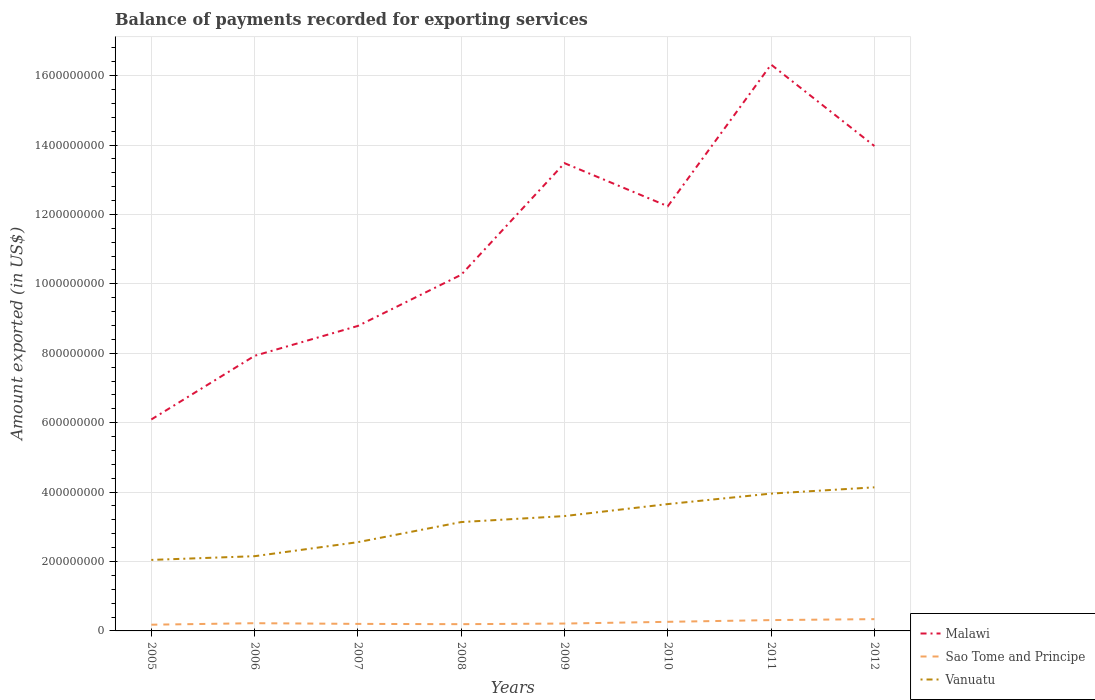How many different coloured lines are there?
Provide a short and direct response. 3. Does the line corresponding to Sao Tome and Principe intersect with the line corresponding to Malawi?
Your response must be concise. No. Is the number of lines equal to the number of legend labels?
Offer a very short reply. Yes. Across all years, what is the maximum amount exported in Sao Tome and Principe?
Your answer should be very brief. 1.79e+07. In which year was the amount exported in Vanuatu maximum?
Make the answer very short. 2005. What is the total amount exported in Sao Tome and Principe in the graph?
Your answer should be compact. 1.01e+06. What is the difference between the highest and the second highest amount exported in Sao Tome and Principe?
Ensure brevity in your answer.  1.60e+07. Is the amount exported in Vanuatu strictly greater than the amount exported in Malawi over the years?
Offer a terse response. Yes. How many lines are there?
Keep it short and to the point. 3. What is the difference between two consecutive major ticks on the Y-axis?
Your response must be concise. 2.00e+08. Are the values on the major ticks of Y-axis written in scientific E-notation?
Your answer should be compact. No. Does the graph contain any zero values?
Your response must be concise. No. Where does the legend appear in the graph?
Your response must be concise. Bottom right. What is the title of the graph?
Your answer should be compact. Balance of payments recorded for exporting services. What is the label or title of the X-axis?
Give a very brief answer. Years. What is the label or title of the Y-axis?
Your response must be concise. Amount exported (in US$). What is the Amount exported (in US$) of Malawi in 2005?
Your answer should be compact. 6.09e+08. What is the Amount exported (in US$) in Sao Tome and Principe in 2005?
Your response must be concise. 1.79e+07. What is the Amount exported (in US$) of Vanuatu in 2005?
Your answer should be very brief. 2.05e+08. What is the Amount exported (in US$) of Malawi in 2006?
Your answer should be very brief. 7.93e+08. What is the Amount exported (in US$) in Sao Tome and Principe in 2006?
Provide a succinct answer. 2.23e+07. What is the Amount exported (in US$) of Vanuatu in 2006?
Provide a succinct answer. 2.15e+08. What is the Amount exported (in US$) of Malawi in 2007?
Your response must be concise. 8.79e+08. What is the Amount exported (in US$) of Sao Tome and Principe in 2007?
Offer a terse response. 2.03e+07. What is the Amount exported (in US$) of Vanuatu in 2007?
Provide a succinct answer. 2.56e+08. What is the Amount exported (in US$) in Malawi in 2008?
Your response must be concise. 1.03e+09. What is the Amount exported (in US$) in Sao Tome and Principe in 2008?
Provide a short and direct response. 1.94e+07. What is the Amount exported (in US$) of Vanuatu in 2008?
Offer a very short reply. 3.14e+08. What is the Amount exported (in US$) in Malawi in 2009?
Give a very brief answer. 1.35e+09. What is the Amount exported (in US$) in Sao Tome and Principe in 2009?
Provide a short and direct response. 2.13e+07. What is the Amount exported (in US$) in Vanuatu in 2009?
Offer a terse response. 3.31e+08. What is the Amount exported (in US$) in Malawi in 2010?
Your answer should be compact. 1.22e+09. What is the Amount exported (in US$) of Sao Tome and Principe in 2010?
Offer a terse response. 2.62e+07. What is the Amount exported (in US$) of Vanuatu in 2010?
Your response must be concise. 3.65e+08. What is the Amount exported (in US$) of Malawi in 2011?
Your answer should be very brief. 1.63e+09. What is the Amount exported (in US$) in Sao Tome and Principe in 2011?
Offer a very short reply. 3.12e+07. What is the Amount exported (in US$) of Vanuatu in 2011?
Offer a terse response. 3.96e+08. What is the Amount exported (in US$) of Malawi in 2012?
Give a very brief answer. 1.40e+09. What is the Amount exported (in US$) of Sao Tome and Principe in 2012?
Give a very brief answer. 3.40e+07. What is the Amount exported (in US$) in Vanuatu in 2012?
Make the answer very short. 4.14e+08. Across all years, what is the maximum Amount exported (in US$) in Malawi?
Ensure brevity in your answer.  1.63e+09. Across all years, what is the maximum Amount exported (in US$) in Sao Tome and Principe?
Make the answer very short. 3.40e+07. Across all years, what is the maximum Amount exported (in US$) of Vanuatu?
Give a very brief answer. 4.14e+08. Across all years, what is the minimum Amount exported (in US$) of Malawi?
Provide a succinct answer. 6.09e+08. Across all years, what is the minimum Amount exported (in US$) in Sao Tome and Principe?
Your response must be concise. 1.79e+07. Across all years, what is the minimum Amount exported (in US$) in Vanuatu?
Offer a very short reply. 2.05e+08. What is the total Amount exported (in US$) of Malawi in the graph?
Make the answer very short. 8.91e+09. What is the total Amount exported (in US$) of Sao Tome and Principe in the graph?
Your answer should be compact. 1.93e+08. What is the total Amount exported (in US$) in Vanuatu in the graph?
Your answer should be very brief. 2.50e+09. What is the difference between the Amount exported (in US$) in Malawi in 2005 and that in 2006?
Keep it short and to the point. -1.83e+08. What is the difference between the Amount exported (in US$) of Sao Tome and Principe in 2005 and that in 2006?
Your response must be concise. -4.35e+06. What is the difference between the Amount exported (in US$) of Vanuatu in 2005 and that in 2006?
Provide a succinct answer. -1.07e+07. What is the difference between the Amount exported (in US$) of Malawi in 2005 and that in 2007?
Make the answer very short. -2.70e+08. What is the difference between the Amount exported (in US$) of Sao Tome and Principe in 2005 and that in 2007?
Offer a terse response. -2.36e+06. What is the difference between the Amount exported (in US$) in Vanuatu in 2005 and that in 2007?
Give a very brief answer. -5.11e+07. What is the difference between the Amount exported (in US$) in Malawi in 2005 and that in 2008?
Keep it short and to the point. -4.17e+08. What is the difference between the Amount exported (in US$) of Sao Tome and Principe in 2005 and that in 2008?
Your answer should be very brief. -1.53e+06. What is the difference between the Amount exported (in US$) of Vanuatu in 2005 and that in 2008?
Your answer should be compact. -1.09e+08. What is the difference between the Amount exported (in US$) of Malawi in 2005 and that in 2009?
Your answer should be compact. -7.39e+08. What is the difference between the Amount exported (in US$) in Sao Tome and Principe in 2005 and that in 2009?
Make the answer very short. -3.34e+06. What is the difference between the Amount exported (in US$) in Vanuatu in 2005 and that in 2009?
Provide a succinct answer. -1.26e+08. What is the difference between the Amount exported (in US$) of Malawi in 2005 and that in 2010?
Make the answer very short. -6.14e+08. What is the difference between the Amount exported (in US$) of Sao Tome and Principe in 2005 and that in 2010?
Provide a succinct answer. -8.30e+06. What is the difference between the Amount exported (in US$) of Vanuatu in 2005 and that in 2010?
Your answer should be very brief. -1.61e+08. What is the difference between the Amount exported (in US$) of Malawi in 2005 and that in 2011?
Your response must be concise. -1.02e+09. What is the difference between the Amount exported (in US$) in Sao Tome and Principe in 2005 and that in 2011?
Provide a short and direct response. -1.33e+07. What is the difference between the Amount exported (in US$) of Vanuatu in 2005 and that in 2011?
Give a very brief answer. -1.91e+08. What is the difference between the Amount exported (in US$) of Malawi in 2005 and that in 2012?
Keep it short and to the point. -7.88e+08. What is the difference between the Amount exported (in US$) in Sao Tome and Principe in 2005 and that in 2012?
Provide a short and direct response. -1.60e+07. What is the difference between the Amount exported (in US$) in Vanuatu in 2005 and that in 2012?
Offer a very short reply. -2.09e+08. What is the difference between the Amount exported (in US$) in Malawi in 2006 and that in 2007?
Offer a very short reply. -8.61e+07. What is the difference between the Amount exported (in US$) of Sao Tome and Principe in 2006 and that in 2007?
Keep it short and to the point. 1.99e+06. What is the difference between the Amount exported (in US$) in Vanuatu in 2006 and that in 2007?
Give a very brief answer. -4.04e+07. What is the difference between the Amount exported (in US$) in Malawi in 2006 and that in 2008?
Your answer should be compact. -2.33e+08. What is the difference between the Amount exported (in US$) of Sao Tome and Principe in 2006 and that in 2008?
Give a very brief answer. 2.82e+06. What is the difference between the Amount exported (in US$) of Vanuatu in 2006 and that in 2008?
Offer a very short reply. -9.83e+07. What is the difference between the Amount exported (in US$) in Malawi in 2006 and that in 2009?
Your response must be concise. -5.55e+08. What is the difference between the Amount exported (in US$) of Sao Tome and Principe in 2006 and that in 2009?
Ensure brevity in your answer.  1.01e+06. What is the difference between the Amount exported (in US$) of Vanuatu in 2006 and that in 2009?
Give a very brief answer. -1.16e+08. What is the difference between the Amount exported (in US$) in Malawi in 2006 and that in 2010?
Ensure brevity in your answer.  -4.31e+08. What is the difference between the Amount exported (in US$) of Sao Tome and Principe in 2006 and that in 2010?
Offer a very short reply. -3.94e+06. What is the difference between the Amount exported (in US$) in Vanuatu in 2006 and that in 2010?
Give a very brief answer. -1.50e+08. What is the difference between the Amount exported (in US$) of Malawi in 2006 and that in 2011?
Keep it short and to the point. -8.39e+08. What is the difference between the Amount exported (in US$) in Sao Tome and Principe in 2006 and that in 2011?
Make the answer very short. -8.94e+06. What is the difference between the Amount exported (in US$) of Vanuatu in 2006 and that in 2011?
Ensure brevity in your answer.  -1.80e+08. What is the difference between the Amount exported (in US$) in Malawi in 2006 and that in 2012?
Ensure brevity in your answer.  -6.05e+08. What is the difference between the Amount exported (in US$) of Sao Tome and Principe in 2006 and that in 2012?
Your answer should be compact. -1.17e+07. What is the difference between the Amount exported (in US$) in Vanuatu in 2006 and that in 2012?
Your answer should be very brief. -1.98e+08. What is the difference between the Amount exported (in US$) in Malawi in 2007 and that in 2008?
Give a very brief answer. -1.47e+08. What is the difference between the Amount exported (in US$) of Sao Tome and Principe in 2007 and that in 2008?
Offer a very short reply. 8.26e+05. What is the difference between the Amount exported (in US$) in Vanuatu in 2007 and that in 2008?
Provide a succinct answer. -5.79e+07. What is the difference between the Amount exported (in US$) in Malawi in 2007 and that in 2009?
Provide a short and direct response. -4.69e+08. What is the difference between the Amount exported (in US$) in Sao Tome and Principe in 2007 and that in 2009?
Your answer should be compact. -9.81e+05. What is the difference between the Amount exported (in US$) of Vanuatu in 2007 and that in 2009?
Offer a very short reply. -7.52e+07. What is the difference between the Amount exported (in US$) of Malawi in 2007 and that in 2010?
Provide a succinct answer. -3.45e+08. What is the difference between the Amount exported (in US$) in Sao Tome and Principe in 2007 and that in 2010?
Provide a succinct answer. -5.93e+06. What is the difference between the Amount exported (in US$) in Vanuatu in 2007 and that in 2010?
Your response must be concise. -1.10e+08. What is the difference between the Amount exported (in US$) in Malawi in 2007 and that in 2011?
Offer a terse response. -7.53e+08. What is the difference between the Amount exported (in US$) in Sao Tome and Principe in 2007 and that in 2011?
Ensure brevity in your answer.  -1.09e+07. What is the difference between the Amount exported (in US$) of Vanuatu in 2007 and that in 2011?
Give a very brief answer. -1.40e+08. What is the difference between the Amount exported (in US$) in Malawi in 2007 and that in 2012?
Offer a very short reply. -5.18e+08. What is the difference between the Amount exported (in US$) in Sao Tome and Principe in 2007 and that in 2012?
Provide a short and direct response. -1.37e+07. What is the difference between the Amount exported (in US$) in Vanuatu in 2007 and that in 2012?
Keep it short and to the point. -1.58e+08. What is the difference between the Amount exported (in US$) of Malawi in 2008 and that in 2009?
Offer a very short reply. -3.22e+08. What is the difference between the Amount exported (in US$) in Sao Tome and Principe in 2008 and that in 2009?
Your response must be concise. -1.81e+06. What is the difference between the Amount exported (in US$) of Vanuatu in 2008 and that in 2009?
Offer a very short reply. -1.73e+07. What is the difference between the Amount exported (in US$) in Malawi in 2008 and that in 2010?
Make the answer very short. -1.97e+08. What is the difference between the Amount exported (in US$) of Sao Tome and Principe in 2008 and that in 2010?
Offer a very short reply. -6.76e+06. What is the difference between the Amount exported (in US$) of Vanuatu in 2008 and that in 2010?
Your answer should be compact. -5.18e+07. What is the difference between the Amount exported (in US$) in Malawi in 2008 and that in 2011?
Provide a short and direct response. -6.06e+08. What is the difference between the Amount exported (in US$) of Sao Tome and Principe in 2008 and that in 2011?
Keep it short and to the point. -1.18e+07. What is the difference between the Amount exported (in US$) of Vanuatu in 2008 and that in 2011?
Your answer should be compact. -8.20e+07. What is the difference between the Amount exported (in US$) in Malawi in 2008 and that in 2012?
Provide a short and direct response. -3.71e+08. What is the difference between the Amount exported (in US$) in Sao Tome and Principe in 2008 and that in 2012?
Provide a short and direct response. -1.45e+07. What is the difference between the Amount exported (in US$) in Vanuatu in 2008 and that in 2012?
Ensure brevity in your answer.  -1.00e+08. What is the difference between the Amount exported (in US$) of Malawi in 2009 and that in 2010?
Provide a succinct answer. 1.24e+08. What is the difference between the Amount exported (in US$) of Sao Tome and Principe in 2009 and that in 2010?
Offer a terse response. -4.95e+06. What is the difference between the Amount exported (in US$) in Vanuatu in 2009 and that in 2010?
Offer a terse response. -3.45e+07. What is the difference between the Amount exported (in US$) in Malawi in 2009 and that in 2011?
Your answer should be very brief. -2.84e+08. What is the difference between the Amount exported (in US$) in Sao Tome and Principe in 2009 and that in 2011?
Give a very brief answer. -9.95e+06. What is the difference between the Amount exported (in US$) in Vanuatu in 2009 and that in 2011?
Offer a terse response. -6.48e+07. What is the difference between the Amount exported (in US$) in Malawi in 2009 and that in 2012?
Ensure brevity in your answer.  -4.94e+07. What is the difference between the Amount exported (in US$) of Sao Tome and Principe in 2009 and that in 2012?
Make the answer very short. -1.27e+07. What is the difference between the Amount exported (in US$) of Vanuatu in 2009 and that in 2012?
Make the answer very short. -8.28e+07. What is the difference between the Amount exported (in US$) in Malawi in 2010 and that in 2011?
Make the answer very short. -4.08e+08. What is the difference between the Amount exported (in US$) in Sao Tome and Principe in 2010 and that in 2011?
Your answer should be very brief. -5.00e+06. What is the difference between the Amount exported (in US$) of Vanuatu in 2010 and that in 2011?
Offer a terse response. -3.03e+07. What is the difference between the Amount exported (in US$) in Malawi in 2010 and that in 2012?
Your response must be concise. -1.74e+08. What is the difference between the Amount exported (in US$) of Sao Tome and Principe in 2010 and that in 2012?
Provide a succinct answer. -7.75e+06. What is the difference between the Amount exported (in US$) of Vanuatu in 2010 and that in 2012?
Offer a very short reply. -4.83e+07. What is the difference between the Amount exported (in US$) of Malawi in 2011 and that in 2012?
Give a very brief answer. 2.35e+08. What is the difference between the Amount exported (in US$) of Sao Tome and Principe in 2011 and that in 2012?
Make the answer very short. -2.75e+06. What is the difference between the Amount exported (in US$) of Vanuatu in 2011 and that in 2012?
Provide a succinct answer. -1.80e+07. What is the difference between the Amount exported (in US$) of Malawi in 2005 and the Amount exported (in US$) of Sao Tome and Principe in 2006?
Your answer should be compact. 5.87e+08. What is the difference between the Amount exported (in US$) of Malawi in 2005 and the Amount exported (in US$) of Vanuatu in 2006?
Ensure brevity in your answer.  3.94e+08. What is the difference between the Amount exported (in US$) in Sao Tome and Principe in 2005 and the Amount exported (in US$) in Vanuatu in 2006?
Your answer should be compact. -1.97e+08. What is the difference between the Amount exported (in US$) in Malawi in 2005 and the Amount exported (in US$) in Sao Tome and Principe in 2007?
Provide a succinct answer. 5.89e+08. What is the difference between the Amount exported (in US$) in Malawi in 2005 and the Amount exported (in US$) in Vanuatu in 2007?
Provide a short and direct response. 3.54e+08. What is the difference between the Amount exported (in US$) of Sao Tome and Principe in 2005 and the Amount exported (in US$) of Vanuatu in 2007?
Keep it short and to the point. -2.38e+08. What is the difference between the Amount exported (in US$) in Malawi in 2005 and the Amount exported (in US$) in Sao Tome and Principe in 2008?
Your answer should be compact. 5.90e+08. What is the difference between the Amount exported (in US$) in Malawi in 2005 and the Amount exported (in US$) in Vanuatu in 2008?
Offer a terse response. 2.96e+08. What is the difference between the Amount exported (in US$) of Sao Tome and Principe in 2005 and the Amount exported (in US$) of Vanuatu in 2008?
Your answer should be compact. -2.96e+08. What is the difference between the Amount exported (in US$) in Malawi in 2005 and the Amount exported (in US$) in Sao Tome and Principe in 2009?
Your answer should be very brief. 5.88e+08. What is the difference between the Amount exported (in US$) in Malawi in 2005 and the Amount exported (in US$) in Vanuatu in 2009?
Your answer should be very brief. 2.78e+08. What is the difference between the Amount exported (in US$) of Sao Tome and Principe in 2005 and the Amount exported (in US$) of Vanuatu in 2009?
Give a very brief answer. -3.13e+08. What is the difference between the Amount exported (in US$) in Malawi in 2005 and the Amount exported (in US$) in Sao Tome and Principe in 2010?
Ensure brevity in your answer.  5.83e+08. What is the difference between the Amount exported (in US$) in Malawi in 2005 and the Amount exported (in US$) in Vanuatu in 2010?
Make the answer very short. 2.44e+08. What is the difference between the Amount exported (in US$) of Sao Tome and Principe in 2005 and the Amount exported (in US$) of Vanuatu in 2010?
Offer a very short reply. -3.48e+08. What is the difference between the Amount exported (in US$) of Malawi in 2005 and the Amount exported (in US$) of Sao Tome and Principe in 2011?
Your response must be concise. 5.78e+08. What is the difference between the Amount exported (in US$) in Malawi in 2005 and the Amount exported (in US$) in Vanuatu in 2011?
Ensure brevity in your answer.  2.14e+08. What is the difference between the Amount exported (in US$) in Sao Tome and Principe in 2005 and the Amount exported (in US$) in Vanuatu in 2011?
Give a very brief answer. -3.78e+08. What is the difference between the Amount exported (in US$) of Malawi in 2005 and the Amount exported (in US$) of Sao Tome and Principe in 2012?
Your response must be concise. 5.75e+08. What is the difference between the Amount exported (in US$) of Malawi in 2005 and the Amount exported (in US$) of Vanuatu in 2012?
Offer a very short reply. 1.96e+08. What is the difference between the Amount exported (in US$) of Sao Tome and Principe in 2005 and the Amount exported (in US$) of Vanuatu in 2012?
Offer a terse response. -3.96e+08. What is the difference between the Amount exported (in US$) of Malawi in 2006 and the Amount exported (in US$) of Sao Tome and Principe in 2007?
Keep it short and to the point. 7.72e+08. What is the difference between the Amount exported (in US$) in Malawi in 2006 and the Amount exported (in US$) in Vanuatu in 2007?
Provide a succinct answer. 5.37e+08. What is the difference between the Amount exported (in US$) of Sao Tome and Principe in 2006 and the Amount exported (in US$) of Vanuatu in 2007?
Your answer should be compact. -2.33e+08. What is the difference between the Amount exported (in US$) of Malawi in 2006 and the Amount exported (in US$) of Sao Tome and Principe in 2008?
Your answer should be very brief. 7.73e+08. What is the difference between the Amount exported (in US$) in Malawi in 2006 and the Amount exported (in US$) in Vanuatu in 2008?
Give a very brief answer. 4.79e+08. What is the difference between the Amount exported (in US$) in Sao Tome and Principe in 2006 and the Amount exported (in US$) in Vanuatu in 2008?
Your answer should be very brief. -2.91e+08. What is the difference between the Amount exported (in US$) in Malawi in 2006 and the Amount exported (in US$) in Sao Tome and Principe in 2009?
Make the answer very short. 7.71e+08. What is the difference between the Amount exported (in US$) of Malawi in 2006 and the Amount exported (in US$) of Vanuatu in 2009?
Provide a succinct answer. 4.62e+08. What is the difference between the Amount exported (in US$) in Sao Tome and Principe in 2006 and the Amount exported (in US$) in Vanuatu in 2009?
Your response must be concise. -3.09e+08. What is the difference between the Amount exported (in US$) in Malawi in 2006 and the Amount exported (in US$) in Sao Tome and Principe in 2010?
Provide a succinct answer. 7.67e+08. What is the difference between the Amount exported (in US$) of Malawi in 2006 and the Amount exported (in US$) of Vanuatu in 2010?
Provide a succinct answer. 4.27e+08. What is the difference between the Amount exported (in US$) of Sao Tome and Principe in 2006 and the Amount exported (in US$) of Vanuatu in 2010?
Offer a terse response. -3.43e+08. What is the difference between the Amount exported (in US$) in Malawi in 2006 and the Amount exported (in US$) in Sao Tome and Principe in 2011?
Provide a short and direct response. 7.62e+08. What is the difference between the Amount exported (in US$) in Malawi in 2006 and the Amount exported (in US$) in Vanuatu in 2011?
Provide a succinct answer. 3.97e+08. What is the difference between the Amount exported (in US$) of Sao Tome and Principe in 2006 and the Amount exported (in US$) of Vanuatu in 2011?
Your answer should be very brief. -3.73e+08. What is the difference between the Amount exported (in US$) of Malawi in 2006 and the Amount exported (in US$) of Sao Tome and Principe in 2012?
Your answer should be compact. 7.59e+08. What is the difference between the Amount exported (in US$) in Malawi in 2006 and the Amount exported (in US$) in Vanuatu in 2012?
Provide a short and direct response. 3.79e+08. What is the difference between the Amount exported (in US$) of Sao Tome and Principe in 2006 and the Amount exported (in US$) of Vanuatu in 2012?
Provide a short and direct response. -3.91e+08. What is the difference between the Amount exported (in US$) of Malawi in 2007 and the Amount exported (in US$) of Sao Tome and Principe in 2008?
Ensure brevity in your answer.  8.59e+08. What is the difference between the Amount exported (in US$) of Malawi in 2007 and the Amount exported (in US$) of Vanuatu in 2008?
Offer a terse response. 5.65e+08. What is the difference between the Amount exported (in US$) of Sao Tome and Principe in 2007 and the Amount exported (in US$) of Vanuatu in 2008?
Offer a terse response. -2.93e+08. What is the difference between the Amount exported (in US$) in Malawi in 2007 and the Amount exported (in US$) in Sao Tome and Principe in 2009?
Give a very brief answer. 8.58e+08. What is the difference between the Amount exported (in US$) of Malawi in 2007 and the Amount exported (in US$) of Vanuatu in 2009?
Ensure brevity in your answer.  5.48e+08. What is the difference between the Amount exported (in US$) of Sao Tome and Principe in 2007 and the Amount exported (in US$) of Vanuatu in 2009?
Your answer should be very brief. -3.11e+08. What is the difference between the Amount exported (in US$) of Malawi in 2007 and the Amount exported (in US$) of Sao Tome and Principe in 2010?
Offer a very short reply. 8.53e+08. What is the difference between the Amount exported (in US$) of Malawi in 2007 and the Amount exported (in US$) of Vanuatu in 2010?
Your response must be concise. 5.13e+08. What is the difference between the Amount exported (in US$) in Sao Tome and Principe in 2007 and the Amount exported (in US$) in Vanuatu in 2010?
Provide a succinct answer. -3.45e+08. What is the difference between the Amount exported (in US$) in Malawi in 2007 and the Amount exported (in US$) in Sao Tome and Principe in 2011?
Keep it short and to the point. 8.48e+08. What is the difference between the Amount exported (in US$) in Malawi in 2007 and the Amount exported (in US$) in Vanuatu in 2011?
Provide a succinct answer. 4.83e+08. What is the difference between the Amount exported (in US$) in Sao Tome and Principe in 2007 and the Amount exported (in US$) in Vanuatu in 2011?
Offer a very short reply. -3.75e+08. What is the difference between the Amount exported (in US$) of Malawi in 2007 and the Amount exported (in US$) of Sao Tome and Principe in 2012?
Your response must be concise. 8.45e+08. What is the difference between the Amount exported (in US$) in Malawi in 2007 and the Amount exported (in US$) in Vanuatu in 2012?
Give a very brief answer. 4.65e+08. What is the difference between the Amount exported (in US$) in Sao Tome and Principe in 2007 and the Amount exported (in US$) in Vanuatu in 2012?
Ensure brevity in your answer.  -3.93e+08. What is the difference between the Amount exported (in US$) in Malawi in 2008 and the Amount exported (in US$) in Sao Tome and Principe in 2009?
Your answer should be very brief. 1.00e+09. What is the difference between the Amount exported (in US$) in Malawi in 2008 and the Amount exported (in US$) in Vanuatu in 2009?
Provide a succinct answer. 6.95e+08. What is the difference between the Amount exported (in US$) in Sao Tome and Principe in 2008 and the Amount exported (in US$) in Vanuatu in 2009?
Give a very brief answer. -3.11e+08. What is the difference between the Amount exported (in US$) in Malawi in 2008 and the Amount exported (in US$) in Sao Tome and Principe in 2010?
Offer a terse response. 1.00e+09. What is the difference between the Amount exported (in US$) in Malawi in 2008 and the Amount exported (in US$) in Vanuatu in 2010?
Provide a short and direct response. 6.61e+08. What is the difference between the Amount exported (in US$) of Sao Tome and Principe in 2008 and the Amount exported (in US$) of Vanuatu in 2010?
Your answer should be very brief. -3.46e+08. What is the difference between the Amount exported (in US$) in Malawi in 2008 and the Amount exported (in US$) in Sao Tome and Principe in 2011?
Give a very brief answer. 9.95e+08. What is the difference between the Amount exported (in US$) of Malawi in 2008 and the Amount exported (in US$) of Vanuatu in 2011?
Your response must be concise. 6.30e+08. What is the difference between the Amount exported (in US$) in Sao Tome and Principe in 2008 and the Amount exported (in US$) in Vanuatu in 2011?
Give a very brief answer. -3.76e+08. What is the difference between the Amount exported (in US$) in Malawi in 2008 and the Amount exported (in US$) in Sao Tome and Principe in 2012?
Keep it short and to the point. 9.92e+08. What is the difference between the Amount exported (in US$) of Malawi in 2008 and the Amount exported (in US$) of Vanuatu in 2012?
Offer a terse response. 6.12e+08. What is the difference between the Amount exported (in US$) in Sao Tome and Principe in 2008 and the Amount exported (in US$) in Vanuatu in 2012?
Your answer should be very brief. -3.94e+08. What is the difference between the Amount exported (in US$) in Malawi in 2009 and the Amount exported (in US$) in Sao Tome and Principe in 2010?
Make the answer very short. 1.32e+09. What is the difference between the Amount exported (in US$) of Malawi in 2009 and the Amount exported (in US$) of Vanuatu in 2010?
Offer a terse response. 9.82e+08. What is the difference between the Amount exported (in US$) of Sao Tome and Principe in 2009 and the Amount exported (in US$) of Vanuatu in 2010?
Your answer should be compact. -3.44e+08. What is the difference between the Amount exported (in US$) of Malawi in 2009 and the Amount exported (in US$) of Sao Tome and Principe in 2011?
Offer a very short reply. 1.32e+09. What is the difference between the Amount exported (in US$) in Malawi in 2009 and the Amount exported (in US$) in Vanuatu in 2011?
Provide a succinct answer. 9.52e+08. What is the difference between the Amount exported (in US$) in Sao Tome and Principe in 2009 and the Amount exported (in US$) in Vanuatu in 2011?
Offer a terse response. -3.74e+08. What is the difference between the Amount exported (in US$) in Malawi in 2009 and the Amount exported (in US$) in Sao Tome and Principe in 2012?
Keep it short and to the point. 1.31e+09. What is the difference between the Amount exported (in US$) in Malawi in 2009 and the Amount exported (in US$) in Vanuatu in 2012?
Offer a terse response. 9.34e+08. What is the difference between the Amount exported (in US$) in Sao Tome and Principe in 2009 and the Amount exported (in US$) in Vanuatu in 2012?
Provide a short and direct response. -3.93e+08. What is the difference between the Amount exported (in US$) in Malawi in 2010 and the Amount exported (in US$) in Sao Tome and Principe in 2011?
Ensure brevity in your answer.  1.19e+09. What is the difference between the Amount exported (in US$) in Malawi in 2010 and the Amount exported (in US$) in Vanuatu in 2011?
Your answer should be very brief. 8.28e+08. What is the difference between the Amount exported (in US$) of Sao Tome and Principe in 2010 and the Amount exported (in US$) of Vanuatu in 2011?
Make the answer very short. -3.70e+08. What is the difference between the Amount exported (in US$) in Malawi in 2010 and the Amount exported (in US$) in Sao Tome and Principe in 2012?
Make the answer very short. 1.19e+09. What is the difference between the Amount exported (in US$) of Malawi in 2010 and the Amount exported (in US$) of Vanuatu in 2012?
Keep it short and to the point. 8.10e+08. What is the difference between the Amount exported (in US$) in Sao Tome and Principe in 2010 and the Amount exported (in US$) in Vanuatu in 2012?
Provide a short and direct response. -3.88e+08. What is the difference between the Amount exported (in US$) in Malawi in 2011 and the Amount exported (in US$) in Sao Tome and Principe in 2012?
Keep it short and to the point. 1.60e+09. What is the difference between the Amount exported (in US$) in Malawi in 2011 and the Amount exported (in US$) in Vanuatu in 2012?
Ensure brevity in your answer.  1.22e+09. What is the difference between the Amount exported (in US$) of Sao Tome and Principe in 2011 and the Amount exported (in US$) of Vanuatu in 2012?
Your response must be concise. -3.83e+08. What is the average Amount exported (in US$) of Malawi per year?
Ensure brevity in your answer.  1.11e+09. What is the average Amount exported (in US$) of Sao Tome and Principe per year?
Give a very brief answer. 2.41e+07. What is the average Amount exported (in US$) in Vanuatu per year?
Your response must be concise. 3.12e+08. In the year 2005, what is the difference between the Amount exported (in US$) in Malawi and Amount exported (in US$) in Sao Tome and Principe?
Ensure brevity in your answer.  5.91e+08. In the year 2005, what is the difference between the Amount exported (in US$) in Malawi and Amount exported (in US$) in Vanuatu?
Your response must be concise. 4.05e+08. In the year 2005, what is the difference between the Amount exported (in US$) of Sao Tome and Principe and Amount exported (in US$) of Vanuatu?
Give a very brief answer. -1.87e+08. In the year 2006, what is the difference between the Amount exported (in US$) of Malawi and Amount exported (in US$) of Sao Tome and Principe?
Your answer should be compact. 7.70e+08. In the year 2006, what is the difference between the Amount exported (in US$) of Malawi and Amount exported (in US$) of Vanuatu?
Make the answer very short. 5.77e+08. In the year 2006, what is the difference between the Amount exported (in US$) in Sao Tome and Principe and Amount exported (in US$) in Vanuatu?
Give a very brief answer. -1.93e+08. In the year 2007, what is the difference between the Amount exported (in US$) of Malawi and Amount exported (in US$) of Sao Tome and Principe?
Give a very brief answer. 8.59e+08. In the year 2007, what is the difference between the Amount exported (in US$) in Malawi and Amount exported (in US$) in Vanuatu?
Make the answer very short. 6.23e+08. In the year 2007, what is the difference between the Amount exported (in US$) in Sao Tome and Principe and Amount exported (in US$) in Vanuatu?
Provide a succinct answer. -2.35e+08. In the year 2008, what is the difference between the Amount exported (in US$) of Malawi and Amount exported (in US$) of Sao Tome and Principe?
Offer a terse response. 1.01e+09. In the year 2008, what is the difference between the Amount exported (in US$) in Malawi and Amount exported (in US$) in Vanuatu?
Provide a succinct answer. 7.13e+08. In the year 2008, what is the difference between the Amount exported (in US$) of Sao Tome and Principe and Amount exported (in US$) of Vanuatu?
Give a very brief answer. -2.94e+08. In the year 2009, what is the difference between the Amount exported (in US$) of Malawi and Amount exported (in US$) of Sao Tome and Principe?
Offer a very short reply. 1.33e+09. In the year 2009, what is the difference between the Amount exported (in US$) of Malawi and Amount exported (in US$) of Vanuatu?
Ensure brevity in your answer.  1.02e+09. In the year 2009, what is the difference between the Amount exported (in US$) of Sao Tome and Principe and Amount exported (in US$) of Vanuatu?
Your answer should be very brief. -3.10e+08. In the year 2010, what is the difference between the Amount exported (in US$) of Malawi and Amount exported (in US$) of Sao Tome and Principe?
Provide a succinct answer. 1.20e+09. In the year 2010, what is the difference between the Amount exported (in US$) of Malawi and Amount exported (in US$) of Vanuatu?
Your answer should be compact. 8.58e+08. In the year 2010, what is the difference between the Amount exported (in US$) of Sao Tome and Principe and Amount exported (in US$) of Vanuatu?
Your response must be concise. -3.39e+08. In the year 2011, what is the difference between the Amount exported (in US$) in Malawi and Amount exported (in US$) in Sao Tome and Principe?
Your response must be concise. 1.60e+09. In the year 2011, what is the difference between the Amount exported (in US$) of Malawi and Amount exported (in US$) of Vanuatu?
Ensure brevity in your answer.  1.24e+09. In the year 2011, what is the difference between the Amount exported (in US$) of Sao Tome and Principe and Amount exported (in US$) of Vanuatu?
Provide a succinct answer. -3.65e+08. In the year 2012, what is the difference between the Amount exported (in US$) in Malawi and Amount exported (in US$) in Sao Tome and Principe?
Provide a short and direct response. 1.36e+09. In the year 2012, what is the difference between the Amount exported (in US$) in Malawi and Amount exported (in US$) in Vanuatu?
Keep it short and to the point. 9.84e+08. In the year 2012, what is the difference between the Amount exported (in US$) in Sao Tome and Principe and Amount exported (in US$) in Vanuatu?
Your response must be concise. -3.80e+08. What is the ratio of the Amount exported (in US$) of Malawi in 2005 to that in 2006?
Offer a terse response. 0.77. What is the ratio of the Amount exported (in US$) of Sao Tome and Principe in 2005 to that in 2006?
Your answer should be very brief. 0.8. What is the ratio of the Amount exported (in US$) in Vanuatu in 2005 to that in 2006?
Provide a succinct answer. 0.95. What is the ratio of the Amount exported (in US$) of Malawi in 2005 to that in 2007?
Your response must be concise. 0.69. What is the ratio of the Amount exported (in US$) of Sao Tome and Principe in 2005 to that in 2007?
Offer a very short reply. 0.88. What is the ratio of the Amount exported (in US$) of Vanuatu in 2005 to that in 2007?
Your answer should be compact. 0.8. What is the ratio of the Amount exported (in US$) in Malawi in 2005 to that in 2008?
Provide a short and direct response. 0.59. What is the ratio of the Amount exported (in US$) in Sao Tome and Principe in 2005 to that in 2008?
Give a very brief answer. 0.92. What is the ratio of the Amount exported (in US$) of Vanuatu in 2005 to that in 2008?
Give a very brief answer. 0.65. What is the ratio of the Amount exported (in US$) in Malawi in 2005 to that in 2009?
Your answer should be very brief. 0.45. What is the ratio of the Amount exported (in US$) in Sao Tome and Principe in 2005 to that in 2009?
Ensure brevity in your answer.  0.84. What is the ratio of the Amount exported (in US$) of Vanuatu in 2005 to that in 2009?
Keep it short and to the point. 0.62. What is the ratio of the Amount exported (in US$) of Malawi in 2005 to that in 2010?
Offer a very short reply. 0.5. What is the ratio of the Amount exported (in US$) in Sao Tome and Principe in 2005 to that in 2010?
Your response must be concise. 0.68. What is the ratio of the Amount exported (in US$) of Vanuatu in 2005 to that in 2010?
Provide a short and direct response. 0.56. What is the ratio of the Amount exported (in US$) of Malawi in 2005 to that in 2011?
Provide a short and direct response. 0.37. What is the ratio of the Amount exported (in US$) of Sao Tome and Principe in 2005 to that in 2011?
Offer a terse response. 0.57. What is the ratio of the Amount exported (in US$) of Vanuatu in 2005 to that in 2011?
Offer a terse response. 0.52. What is the ratio of the Amount exported (in US$) in Malawi in 2005 to that in 2012?
Your response must be concise. 0.44. What is the ratio of the Amount exported (in US$) in Sao Tome and Principe in 2005 to that in 2012?
Your answer should be very brief. 0.53. What is the ratio of the Amount exported (in US$) of Vanuatu in 2005 to that in 2012?
Your response must be concise. 0.49. What is the ratio of the Amount exported (in US$) of Malawi in 2006 to that in 2007?
Offer a terse response. 0.9. What is the ratio of the Amount exported (in US$) of Sao Tome and Principe in 2006 to that in 2007?
Your answer should be very brief. 1.1. What is the ratio of the Amount exported (in US$) of Vanuatu in 2006 to that in 2007?
Your response must be concise. 0.84. What is the ratio of the Amount exported (in US$) of Malawi in 2006 to that in 2008?
Offer a terse response. 0.77. What is the ratio of the Amount exported (in US$) in Sao Tome and Principe in 2006 to that in 2008?
Ensure brevity in your answer.  1.15. What is the ratio of the Amount exported (in US$) in Vanuatu in 2006 to that in 2008?
Ensure brevity in your answer.  0.69. What is the ratio of the Amount exported (in US$) in Malawi in 2006 to that in 2009?
Give a very brief answer. 0.59. What is the ratio of the Amount exported (in US$) of Sao Tome and Principe in 2006 to that in 2009?
Provide a succinct answer. 1.05. What is the ratio of the Amount exported (in US$) in Vanuatu in 2006 to that in 2009?
Provide a succinct answer. 0.65. What is the ratio of the Amount exported (in US$) of Malawi in 2006 to that in 2010?
Give a very brief answer. 0.65. What is the ratio of the Amount exported (in US$) in Sao Tome and Principe in 2006 to that in 2010?
Your answer should be very brief. 0.85. What is the ratio of the Amount exported (in US$) in Vanuatu in 2006 to that in 2010?
Provide a short and direct response. 0.59. What is the ratio of the Amount exported (in US$) of Malawi in 2006 to that in 2011?
Keep it short and to the point. 0.49. What is the ratio of the Amount exported (in US$) in Sao Tome and Principe in 2006 to that in 2011?
Provide a short and direct response. 0.71. What is the ratio of the Amount exported (in US$) of Vanuatu in 2006 to that in 2011?
Your answer should be very brief. 0.54. What is the ratio of the Amount exported (in US$) in Malawi in 2006 to that in 2012?
Keep it short and to the point. 0.57. What is the ratio of the Amount exported (in US$) in Sao Tome and Principe in 2006 to that in 2012?
Provide a short and direct response. 0.66. What is the ratio of the Amount exported (in US$) of Vanuatu in 2006 to that in 2012?
Provide a succinct answer. 0.52. What is the ratio of the Amount exported (in US$) of Malawi in 2007 to that in 2008?
Your response must be concise. 0.86. What is the ratio of the Amount exported (in US$) of Sao Tome and Principe in 2007 to that in 2008?
Your answer should be compact. 1.04. What is the ratio of the Amount exported (in US$) of Vanuatu in 2007 to that in 2008?
Give a very brief answer. 0.82. What is the ratio of the Amount exported (in US$) of Malawi in 2007 to that in 2009?
Offer a very short reply. 0.65. What is the ratio of the Amount exported (in US$) of Sao Tome and Principe in 2007 to that in 2009?
Offer a terse response. 0.95. What is the ratio of the Amount exported (in US$) in Vanuatu in 2007 to that in 2009?
Your answer should be very brief. 0.77. What is the ratio of the Amount exported (in US$) in Malawi in 2007 to that in 2010?
Offer a very short reply. 0.72. What is the ratio of the Amount exported (in US$) in Sao Tome and Principe in 2007 to that in 2010?
Provide a short and direct response. 0.77. What is the ratio of the Amount exported (in US$) of Vanuatu in 2007 to that in 2010?
Provide a short and direct response. 0.7. What is the ratio of the Amount exported (in US$) of Malawi in 2007 to that in 2011?
Give a very brief answer. 0.54. What is the ratio of the Amount exported (in US$) of Sao Tome and Principe in 2007 to that in 2011?
Your answer should be compact. 0.65. What is the ratio of the Amount exported (in US$) in Vanuatu in 2007 to that in 2011?
Your response must be concise. 0.65. What is the ratio of the Amount exported (in US$) of Malawi in 2007 to that in 2012?
Provide a short and direct response. 0.63. What is the ratio of the Amount exported (in US$) in Sao Tome and Principe in 2007 to that in 2012?
Ensure brevity in your answer.  0.6. What is the ratio of the Amount exported (in US$) in Vanuatu in 2007 to that in 2012?
Your response must be concise. 0.62. What is the ratio of the Amount exported (in US$) in Malawi in 2008 to that in 2009?
Your answer should be very brief. 0.76. What is the ratio of the Amount exported (in US$) of Sao Tome and Principe in 2008 to that in 2009?
Offer a very short reply. 0.92. What is the ratio of the Amount exported (in US$) in Vanuatu in 2008 to that in 2009?
Offer a very short reply. 0.95. What is the ratio of the Amount exported (in US$) of Malawi in 2008 to that in 2010?
Your answer should be very brief. 0.84. What is the ratio of the Amount exported (in US$) of Sao Tome and Principe in 2008 to that in 2010?
Provide a short and direct response. 0.74. What is the ratio of the Amount exported (in US$) of Vanuatu in 2008 to that in 2010?
Provide a short and direct response. 0.86. What is the ratio of the Amount exported (in US$) in Malawi in 2008 to that in 2011?
Offer a very short reply. 0.63. What is the ratio of the Amount exported (in US$) of Sao Tome and Principe in 2008 to that in 2011?
Keep it short and to the point. 0.62. What is the ratio of the Amount exported (in US$) in Vanuatu in 2008 to that in 2011?
Offer a very short reply. 0.79. What is the ratio of the Amount exported (in US$) of Malawi in 2008 to that in 2012?
Ensure brevity in your answer.  0.73. What is the ratio of the Amount exported (in US$) in Sao Tome and Principe in 2008 to that in 2012?
Your answer should be very brief. 0.57. What is the ratio of the Amount exported (in US$) of Vanuatu in 2008 to that in 2012?
Provide a succinct answer. 0.76. What is the ratio of the Amount exported (in US$) of Malawi in 2009 to that in 2010?
Offer a very short reply. 1.1. What is the ratio of the Amount exported (in US$) in Sao Tome and Principe in 2009 to that in 2010?
Your response must be concise. 0.81. What is the ratio of the Amount exported (in US$) in Vanuatu in 2009 to that in 2010?
Your answer should be very brief. 0.91. What is the ratio of the Amount exported (in US$) of Malawi in 2009 to that in 2011?
Offer a terse response. 0.83. What is the ratio of the Amount exported (in US$) of Sao Tome and Principe in 2009 to that in 2011?
Your answer should be compact. 0.68. What is the ratio of the Amount exported (in US$) in Vanuatu in 2009 to that in 2011?
Offer a terse response. 0.84. What is the ratio of the Amount exported (in US$) of Malawi in 2009 to that in 2012?
Make the answer very short. 0.96. What is the ratio of the Amount exported (in US$) in Sao Tome and Principe in 2009 to that in 2012?
Give a very brief answer. 0.63. What is the ratio of the Amount exported (in US$) in Vanuatu in 2009 to that in 2012?
Keep it short and to the point. 0.8. What is the ratio of the Amount exported (in US$) of Malawi in 2010 to that in 2011?
Offer a terse response. 0.75. What is the ratio of the Amount exported (in US$) of Sao Tome and Principe in 2010 to that in 2011?
Offer a terse response. 0.84. What is the ratio of the Amount exported (in US$) of Vanuatu in 2010 to that in 2011?
Your answer should be compact. 0.92. What is the ratio of the Amount exported (in US$) in Malawi in 2010 to that in 2012?
Provide a short and direct response. 0.88. What is the ratio of the Amount exported (in US$) in Sao Tome and Principe in 2010 to that in 2012?
Keep it short and to the point. 0.77. What is the ratio of the Amount exported (in US$) in Vanuatu in 2010 to that in 2012?
Make the answer very short. 0.88. What is the ratio of the Amount exported (in US$) of Malawi in 2011 to that in 2012?
Give a very brief answer. 1.17. What is the ratio of the Amount exported (in US$) of Sao Tome and Principe in 2011 to that in 2012?
Make the answer very short. 0.92. What is the ratio of the Amount exported (in US$) of Vanuatu in 2011 to that in 2012?
Provide a short and direct response. 0.96. What is the difference between the highest and the second highest Amount exported (in US$) in Malawi?
Make the answer very short. 2.35e+08. What is the difference between the highest and the second highest Amount exported (in US$) in Sao Tome and Principe?
Give a very brief answer. 2.75e+06. What is the difference between the highest and the second highest Amount exported (in US$) of Vanuatu?
Give a very brief answer. 1.80e+07. What is the difference between the highest and the lowest Amount exported (in US$) of Malawi?
Provide a short and direct response. 1.02e+09. What is the difference between the highest and the lowest Amount exported (in US$) of Sao Tome and Principe?
Ensure brevity in your answer.  1.60e+07. What is the difference between the highest and the lowest Amount exported (in US$) of Vanuatu?
Offer a terse response. 2.09e+08. 